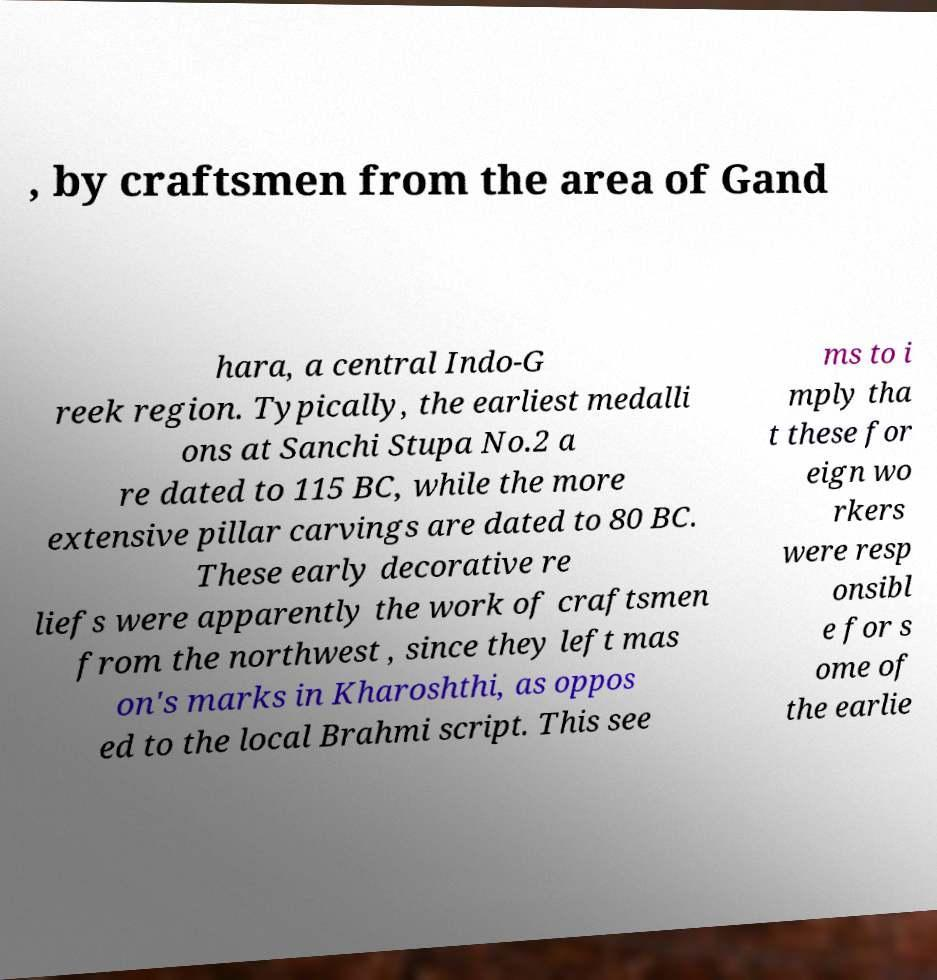Can you read and provide the text displayed in the image?This photo seems to have some interesting text. Can you extract and type it out for me? , by craftsmen from the area of Gand hara, a central Indo-G reek region. Typically, the earliest medalli ons at Sanchi Stupa No.2 a re dated to 115 BC, while the more extensive pillar carvings are dated to 80 BC. These early decorative re liefs were apparently the work of craftsmen from the northwest , since they left mas on's marks in Kharoshthi, as oppos ed to the local Brahmi script. This see ms to i mply tha t these for eign wo rkers were resp onsibl e for s ome of the earlie 